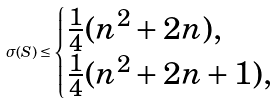Convert formula to latex. <formula><loc_0><loc_0><loc_500><loc_500>\sigma ( S ) \leq \begin{cases} \frac { 1 } { 4 } ( n ^ { 2 } + 2 n ) , & \\ \frac { 1 } { 4 } ( n ^ { 2 } + 2 n + 1 ) , & \end{cases}</formula> 